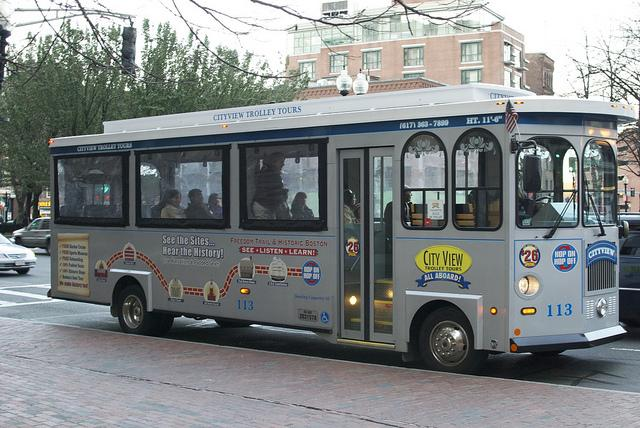What is the bus primarily used for?

Choices:
A) tours
B) racing
C) shipping
D) school tours 